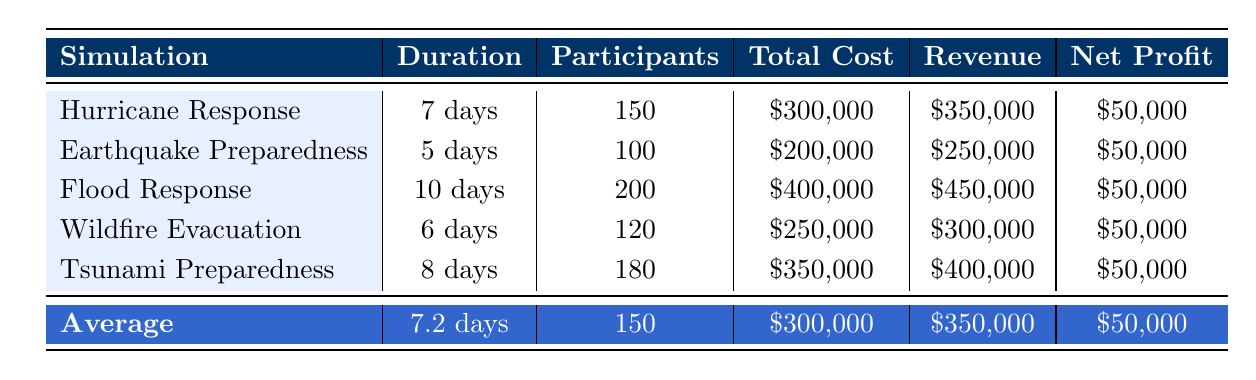What is the total revenue generated from all simulations? To find the total revenue, sum the revenue from each training: 350000 + 250000 + 450000 + 300000 + 400000 = 1750000.
Answer: 1750000 How many participants attended the Flood Response Exercise? The number of participants for the Flood Response Exercise is clearly indicated as 200 in the table.
Answer: 200 Which simulation location has the highest total cost? Examine the total cost for each simulation: Hurricane Response 300000, Earthquake Preparedness 200000, Flood Response 400000, Wildfire Evacuation 250000, Tsunami Preparedness 350000. The Flood Response has the highest total cost of 400000.
Answer: Flood Response Is the net profit for all simulations consistently the same? The net profit for each simulation is 50000, as shown in the table. Therefore, the net profit is consistent across all simulations.
Answer: Yes Calculate the average duration of the simulations. The durations are 7 days, 5 days, 10 days, 6 days, and 8 days. First, sum the durations: 7 + 5 + 10 + 6 + 8 = 36 days. Then divide by the number of simulations (5): 36 / 5 = 7.2 days.
Answer: 7.2 days How much funding did the Earthquake Preparedness Drill receive from grants and sponsorship combined? The grants amount is 40000 and the sponsorship is 15000. Add these amounts together: 40000 + 15000 = 55000.
Answer: 55000 Is the total cost of the Tsunami Preparedness Simulation less than the total cost of the Wildfire Evacuation Drill? The total cost for Tsunami Preparedness is 350000 and for Wildfire Evacuation is 250000. Since 350000 is greater than 250000, this statement is false.
Answer: No Compare the average number of participants across the simulations. The number of participants is 150, 100, 200, 120, and 180. Sum these: 150 + 100 + 200 + 120 + 180 = 850. Divide by 5 (the number of simulations): 850 / 5 = 170.
Answer: 170 Which training had the highest number of personnel hours? The personnel hours for each training are: Hurricane Response 1200, Earthquake Preparedness 900, Flood Response 1500, Wildfire Evacuation 1000, and Tsunami Preparedness 1300. The Flood Response had the highest personnel hours at 1500.
Answer: Flood Response 